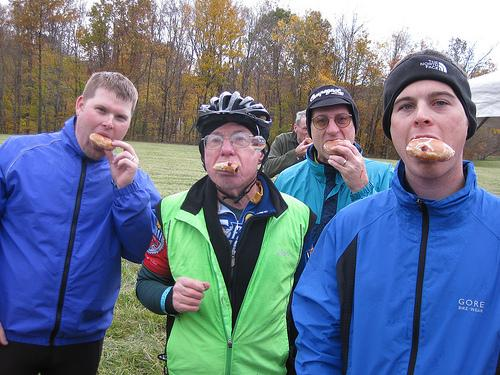List the main elements in the photograph and their relation to one another. Men enjoying doughnuts, wearing various jackets, glasses, and hats; surrounded by fall trees and a helmet on the table. Explain the prominent objects in the image, highlighting the colors and any interesting details. Men are eating doughnuts, wearing jackets, a black wool hat, and glasses; a black and silver helmet rests nearby, and autumn trees complete the scene. Mention the main activity and surroundings in the image. A group of men are eating doughnuts outdoor, among the beautiful scenery of fall trees and their colorful leaves. What are the key components of this image, and how do they create the overall picture? The key components are men eating doughnuts, their clothing items like jackets and hats, and the autumn scenery blending together to create a casual social gathering. Identify the main subject and setting of the image, highlighting any noteworthy features. The main subject of this image is a group of men eating doughnuts outdoors, surrounded by trees displaying fall colors and dressed in distinctive colorful jackets and accessories. Write a short, poetic description of the scene captured in the photo. Amidst the vibrant hues of autumn leaves, a merry band of men partakes in the simple pleasure of sharing doughnuts under the cold white sky. Describe this photograph as an art critic might. This photograph masterfully captures the essence of camaraderie, as subjects clad in colorful jackets and accessories engage in the communal act of enjoying doughnuts amidst a picturesque autumn backdrop. Provide a brief description of the main action taking place in the image. Several men are eating doughnuts together, with trees displaying autumn colors in the background. Tell a short story about the scene in the image. It was a crisp autumn day, and a group of friends gathered outdoors to enjoy some doughnuts together, beneath the golden trees. Create a catchy headline for this image. "Doughnut Delight: A Fall Gathering with Friends and Treats" 